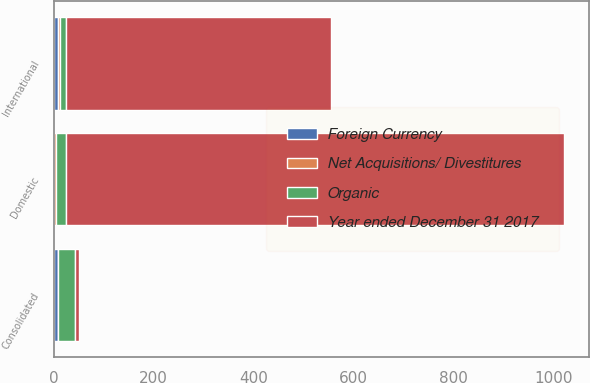<chart> <loc_0><loc_0><loc_500><loc_500><stacked_bar_chart><ecel><fcel>Consolidated<fcel>Domestic<fcel>International<nl><fcel>Year ended December 31 2017<fcel>9.3<fcel>996.1<fcel>531.1<nl><fcel>Foreign Currency<fcel>9.3<fcel>0<fcel>9.3<nl><fcel>Organic<fcel>32.6<fcel>21<fcel>11.6<nl><fcel>Net Acquisitions/ Divestitures<fcel>0.2<fcel>3.9<fcel>3.7<nl></chart> 